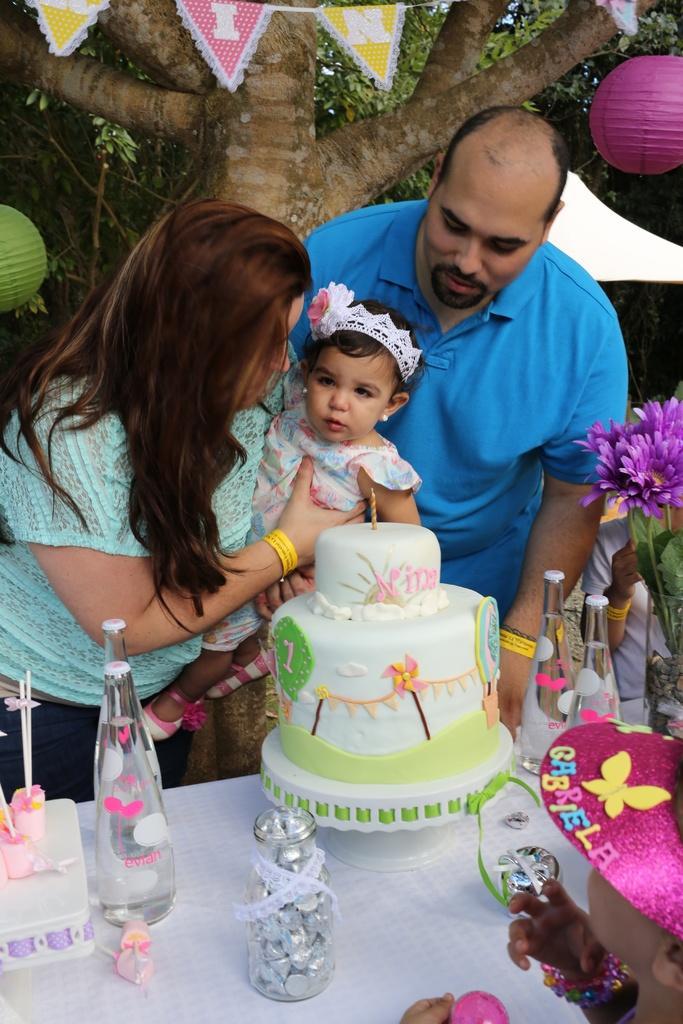Please provide a concise description of this image. In this picture there is a man standing , and a woman standing , a baby which is carried by a woman , and at the table we have jar of chocolates , bottle, cake , hat ,flower bouquet and at the back ground we have tree covered with ribbons and paper lanterns. 